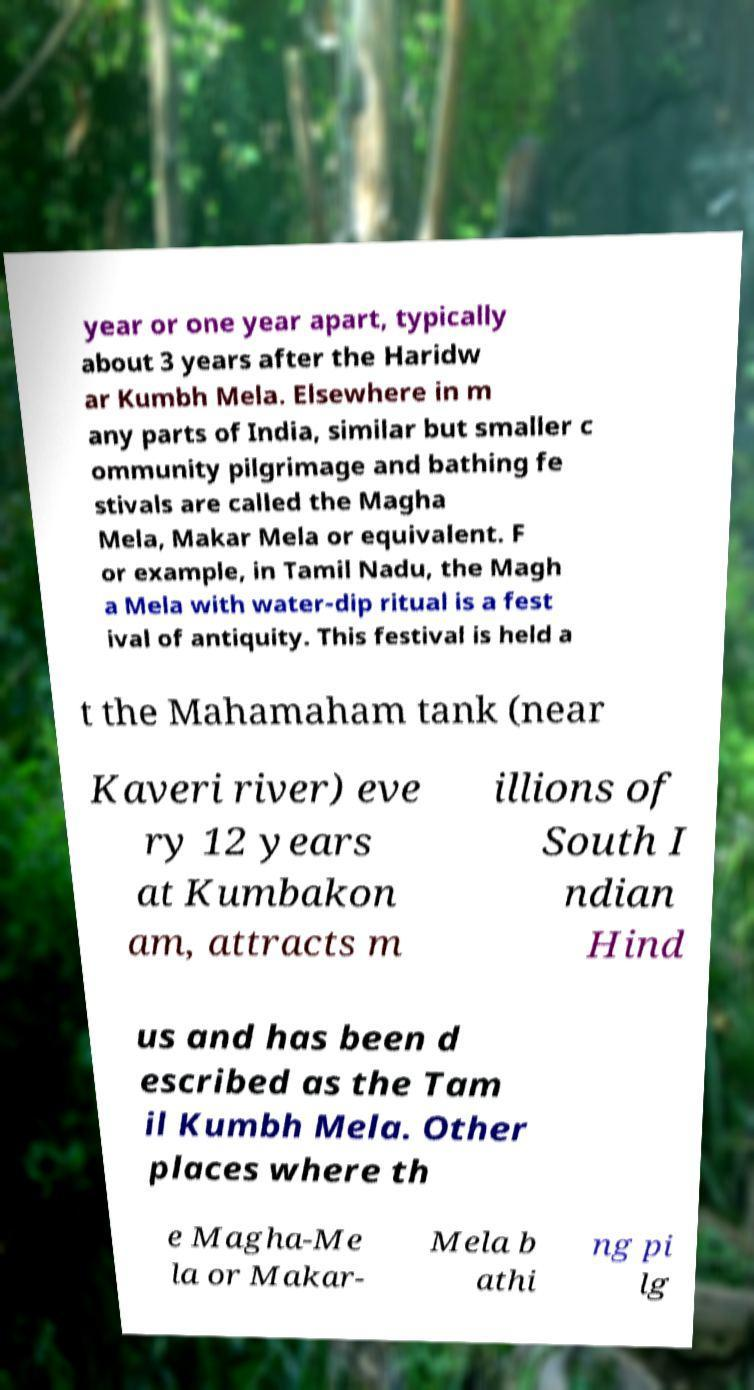There's text embedded in this image that I need extracted. Can you transcribe it verbatim? year or one year apart, typically about 3 years after the Haridw ar Kumbh Mela. Elsewhere in m any parts of India, similar but smaller c ommunity pilgrimage and bathing fe stivals are called the Magha Mela, Makar Mela or equivalent. F or example, in Tamil Nadu, the Magh a Mela with water-dip ritual is a fest ival of antiquity. This festival is held a t the Mahamaham tank (near Kaveri river) eve ry 12 years at Kumbakon am, attracts m illions of South I ndian Hind us and has been d escribed as the Tam il Kumbh Mela. Other places where th e Magha-Me la or Makar- Mela b athi ng pi lg 